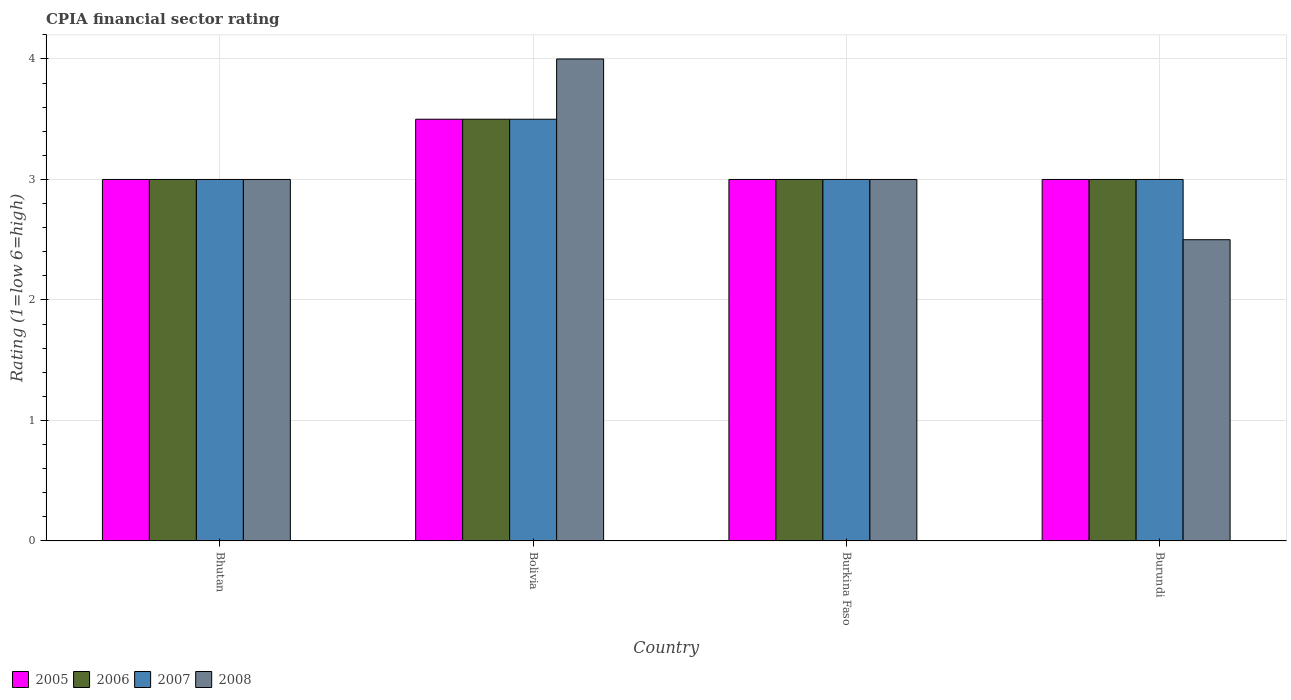How many groups of bars are there?
Offer a terse response. 4. Are the number of bars per tick equal to the number of legend labels?
Your response must be concise. Yes. Are the number of bars on each tick of the X-axis equal?
Ensure brevity in your answer.  Yes. What is the CPIA rating in 2005 in Bhutan?
Your response must be concise. 3. Across all countries, what is the maximum CPIA rating in 2007?
Offer a very short reply. 3.5. Across all countries, what is the minimum CPIA rating in 2005?
Offer a very short reply. 3. In which country was the CPIA rating in 2007 minimum?
Offer a very short reply. Bhutan. What is the total CPIA rating in 2005 in the graph?
Give a very brief answer. 12.5. What is the difference between the CPIA rating in 2005 in Bhutan and that in Bolivia?
Provide a succinct answer. -0.5. What is the average CPIA rating in 2008 per country?
Make the answer very short. 3.12. What is the difference between the CPIA rating of/in 2008 and CPIA rating of/in 2006 in Bolivia?
Ensure brevity in your answer.  0.5. What is the ratio of the CPIA rating in 2007 in Bhutan to that in Burkina Faso?
Ensure brevity in your answer.  1. What is the difference between the highest and the lowest CPIA rating in 2008?
Your answer should be very brief. 1.5. Is it the case that in every country, the sum of the CPIA rating in 2005 and CPIA rating in 2008 is greater than the sum of CPIA rating in 2007 and CPIA rating in 2006?
Provide a succinct answer. No. What does the 2nd bar from the right in Burundi represents?
Ensure brevity in your answer.  2007. What is the difference between two consecutive major ticks on the Y-axis?
Provide a short and direct response. 1. Does the graph contain grids?
Make the answer very short. Yes. What is the title of the graph?
Ensure brevity in your answer.  CPIA financial sector rating. What is the label or title of the X-axis?
Provide a short and direct response. Country. What is the Rating (1=low 6=high) of 2006 in Burkina Faso?
Make the answer very short. 3. What is the Rating (1=low 6=high) of 2008 in Burkina Faso?
Offer a terse response. 3. What is the Rating (1=low 6=high) of 2005 in Burundi?
Give a very brief answer. 3. What is the Rating (1=low 6=high) in 2006 in Burundi?
Your answer should be compact. 3. Across all countries, what is the maximum Rating (1=low 6=high) in 2007?
Make the answer very short. 3.5. Across all countries, what is the minimum Rating (1=low 6=high) in 2007?
Give a very brief answer. 3. What is the difference between the Rating (1=low 6=high) in 2007 in Bhutan and that in Burkina Faso?
Offer a terse response. 0. What is the difference between the Rating (1=low 6=high) of 2008 in Bhutan and that in Burundi?
Keep it short and to the point. 0.5. What is the difference between the Rating (1=low 6=high) in 2005 in Bolivia and that in Burkina Faso?
Offer a terse response. 0.5. What is the difference between the Rating (1=low 6=high) of 2006 in Bolivia and that in Burkina Faso?
Keep it short and to the point. 0.5. What is the difference between the Rating (1=low 6=high) in 2007 in Bolivia and that in Burkina Faso?
Offer a very short reply. 0.5. What is the difference between the Rating (1=low 6=high) in 2008 in Bolivia and that in Burkina Faso?
Give a very brief answer. 1. What is the difference between the Rating (1=low 6=high) of 2005 in Bolivia and that in Burundi?
Provide a succinct answer. 0.5. What is the difference between the Rating (1=low 6=high) in 2006 in Bolivia and that in Burundi?
Make the answer very short. 0.5. What is the difference between the Rating (1=low 6=high) of 2008 in Bolivia and that in Burundi?
Offer a terse response. 1.5. What is the difference between the Rating (1=low 6=high) of 2006 in Burkina Faso and that in Burundi?
Provide a succinct answer. 0. What is the difference between the Rating (1=low 6=high) of 2005 in Bhutan and the Rating (1=low 6=high) of 2006 in Bolivia?
Give a very brief answer. -0.5. What is the difference between the Rating (1=low 6=high) in 2005 in Bhutan and the Rating (1=low 6=high) in 2007 in Bolivia?
Ensure brevity in your answer.  -0.5. What is the difference between the Rating (1=low 6=high) in 2005 in Bhutan and the Rating (1=low 6=high) in 2008 in Bolivia?
Your answer should be compact. -1. What is the difference between the Rating (1=low 6=high) in 2006 in Bhutan and the Rating (1=low 6=high) in 2007 in Bolivia?
Offer a very short reply. -0.5. What is the difference between the Rating (1=low 6=high) of 2005 in Bhutan and the Rating (1=low 6=high) of 2006 in Burkina Faso?
Keep it short and to the point. 0. What is the difference between the Rating (1=low 6=high) in 2005 in Bhutan and the Rating (1=low 6=high) in 2007 in Burkina Faso?
Your response must be concise. 0. What is the difference between the Rating (1=low 6=high) of 2006 in Bhutan and the Rating (1=low 6=high) of 2008 in Burkina Faso?
Ensure brevity in your answer.  0. What is the difference between the Rating (1=low 6=high) in 2007 in Bhutan and the Rating (1=low 6=high) in 2008 in Burkina Faso?
Your response must be concise. 0. What is the difference between the Rating (1=low 6=high) in 2005 in Bhutan and the Rating (1=low 6=high) in 2007 in Burundi?
Ensure brevity in your answer.  0. What is the difference between the Rating (1=low 6=high) of 2005 in Bhutan and the Rating (1=low 6=high) of 2008 in Burundi?
Give a very brief answer. 0.5. What is the difference between the Rating (1=low 6=high) in 2006 in Bhutan and the Rating (1=low 6=high) in 2008 in Burundi?
Provide a succinct answer. 0.5. What is the difference between the Rating (1=low 6=high) in 2007 in Bhutan and the Rating (1=low 6=high) in 2008 in Burundi?
Make the answer very short. 0.5. What is the difference between the Rating (1=low 6=high) in 2005 in Bolivia and the Rating (1=low 6=high) in 2006 in Burkina Faso?
Keep it short and to the point. 0.5. What is the difference between the Rating (1=low 6=high) in 2005 in Bolivia and the Rating (1=low 6=high) in 2007 in Burkina Faso?
Your answer should be very brief. 0.5. What is the difference between the Rating (1=low 6=high) in 2005 in Bolivia and the Rating (1=low 6=high) in 2008 in Burkina Faso?
Keep it short and to the point. 0.5. What is the difference between the Rating (1=low 6=high) of 2006 in Bolivia and the Rating (1=low 6=high) of 2008 in Burkina Faso?
Your response must be concise. 0.5. What is the difference between the Rating (1=low 6=high) of 2006 in Bolivia and the Rating (1=low 6=high) of 2007 in Burundi?
Provide a short and direct response. 0.5. What is the difference between the Rating (1=low 6=high) in 2006 in Bolivia and the Rating (1=low 6=high) in 2008 in Burundi?
Give a very brief answer. 1. What is the difference between the Rating (1=low 6=high) of 2007 in Bolivia and the Rating (1=low 6=high) of 2008 in Burundi?
Offer a very short reply. 1. What is the difference between the Rating (1=low 6=high) in 2006 in Burkina Faso and the Rating (1=low 6=high) in 2007 in Burundi?
Make the answer very short. 0. What is the difference between the Rating (1=low 6=high) in 2006 in Burkina Faso and the Rating (1=low 6=high) in 2008 in Burundi?
Your response must be concise. 0.5. What is the average Rating (1=low 6=high) of 2005 per country?
Offer a terse response. 3.12. What is the average Rating (1=low 6=high) of 2006 per country?
Offer a terse response. 3.12. What is the average Rating (1=low 6=high) in 2007 per country?
Your answer should be very brief. 3.12. What is the average Rating (1=low 6=high) in 2008 per country?
Offer a very short reply. 3.12. What is the difference between the Rating (1=low 6=high) of 2005 and Rating (1=low 6=high) of 2006 in Bhutan?
Make the answer very short. 0. What is the difference between the Rating (1=low 6=high) of 2006 and Rating (1=low 6=high) of 2008 in Bhutan?
Provide a succinct answer. 0. What is the difference between the Rating (1=low 6=high) in 2007 and Rating (1=low 6=high) in 2008 in Bhutan?
Make the answer very short. 0. What is the difference between the Rating (1=low 6=high) of 2005 and Rating (1=low 6=high) of 2008 in Bolivia?
Offer a very short reply. -0.5. What is the difference between the Rating (1=low 6=high) in 2007 and Rating (1=low 6=high) in 2008 in Burkina Faso?
Your answer should be very brief. 0. What is the difference between the Rating (1=low 6=high) in 2005 and Rating (1=low 6=high) in 2007 in Burundi?
Offer a terse response. 0. What is the difference between the Rating (1=low 6=high) in 2005 and Rating (1=low 6=high) in 2008 in Burundi?
Your answer should be compact. 0.5. What is the ratio of the Rating (1=low 6=high) in 2005 in Bhutan to that in Bolivia?
Ensure brevity in your answer.  0.86. What is the ratio of the Rating (1=low 6=high) of 2008 in Bhutan to that in Bolivia?
Keep it short and to the point. 0.75. What is the ratio of the Rating (1=low 6=high) in 2005 in Bhutan to that in Burkina Faso?
Your response must be concise. 1. What is the ratio of the Rating (1=low 6=high) of 2007 in Bhutan to that in Burkina Faso?
Give a very brief answer. 1. What is the ratio of the Rating (1=low 6=high) of 2008 in Bhutan to that in Burkina Faso?
Give a very brief answer. 1. What is the ratio of the Rating (1=low 6=high) of 2006 in Bhutan to that in Burundi?
Your response must be concise. 1. What is the ratio of the Rating (1=low 6=high) in 2007 in Bhutan to that in Burundi?
Your answer should be compact. 1. What is the ratio of the Rating (1=low 6=high) of 2008 in Bhutan to that in Burundi?
Your answer should be compact. 1.2. What is the ratio of the Rating (1=low 6=high) in 2005 in Bolivia to that in Burkina Faso?
Keep it short and to the point. 1.17. What is the ratio of the Rating (1=low 6=high) of 2006 in Bolivia to that in Burkina Faso?
Your answer should be very brief. 1.17. What is the ratio of the Rating (1=low 6=high) of 2005 in Burkina Faso to that in Burundi?
Your answer should be very brief. 1. What is the ratio of the Rating (1=low 6=high) of 2006 in Burkina Faso to that in Burundi?
Provide a succinct answer. 1. What is the ratio of the Rating (1=low 6=high) in 2007 in Burkina Faso to that in Burundi?
Make the answer very short. 1. What is the ratio of the Rating (1=low 6=high) in 2008 in Burkina Faso to that in Burundi?
Ensure brevity in your answer.  1.2. What is the difference between the highest and the second highest Rating (1=low 6=high) of 2005?
Ensure brevity in your answer.  0.5. What is the difference between the highest and the second highest Rating (1=low 6=high) of 2007?
Provide a short and direct response. 0.5. What is the difference between the highest and the second highest Rating (1=low 6=high) of 2008?
Offer a very short reply. 1. What is the difference between the highest and the lowest Rating (1=low 6=high) of 2007?
Give a very brief answer. 0.5. 